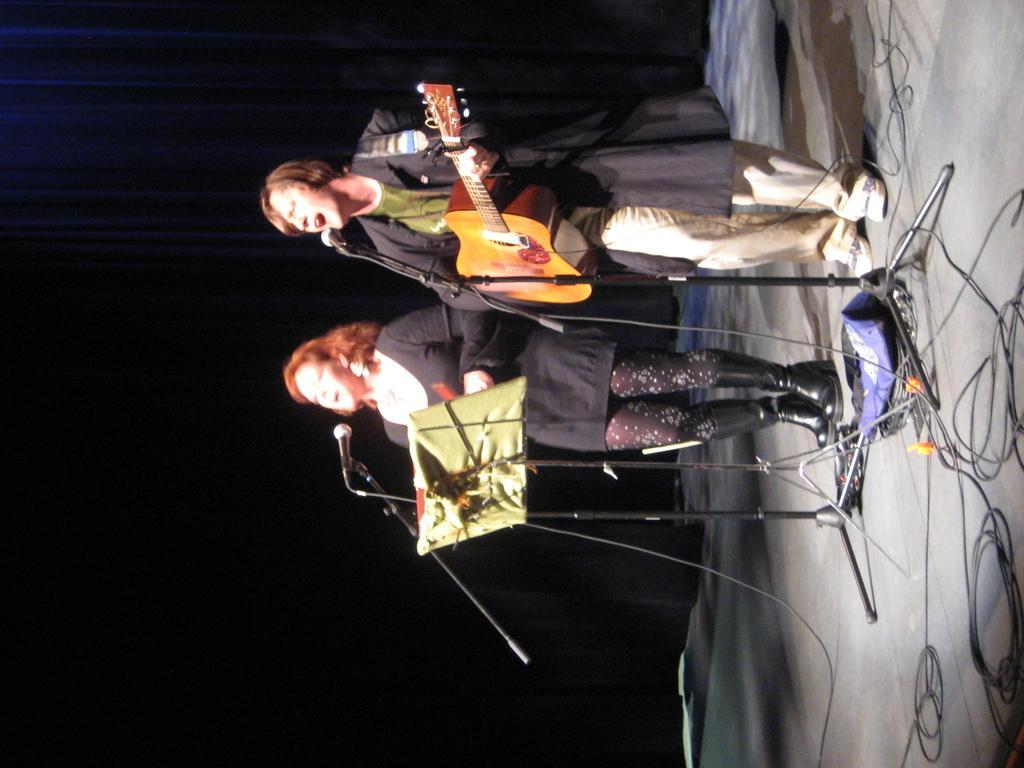Can you describe this image briefly? A woman is singing with mic and stand in front of her. There is another woman standing beside her playing guitar. There is a black screen behind them. 